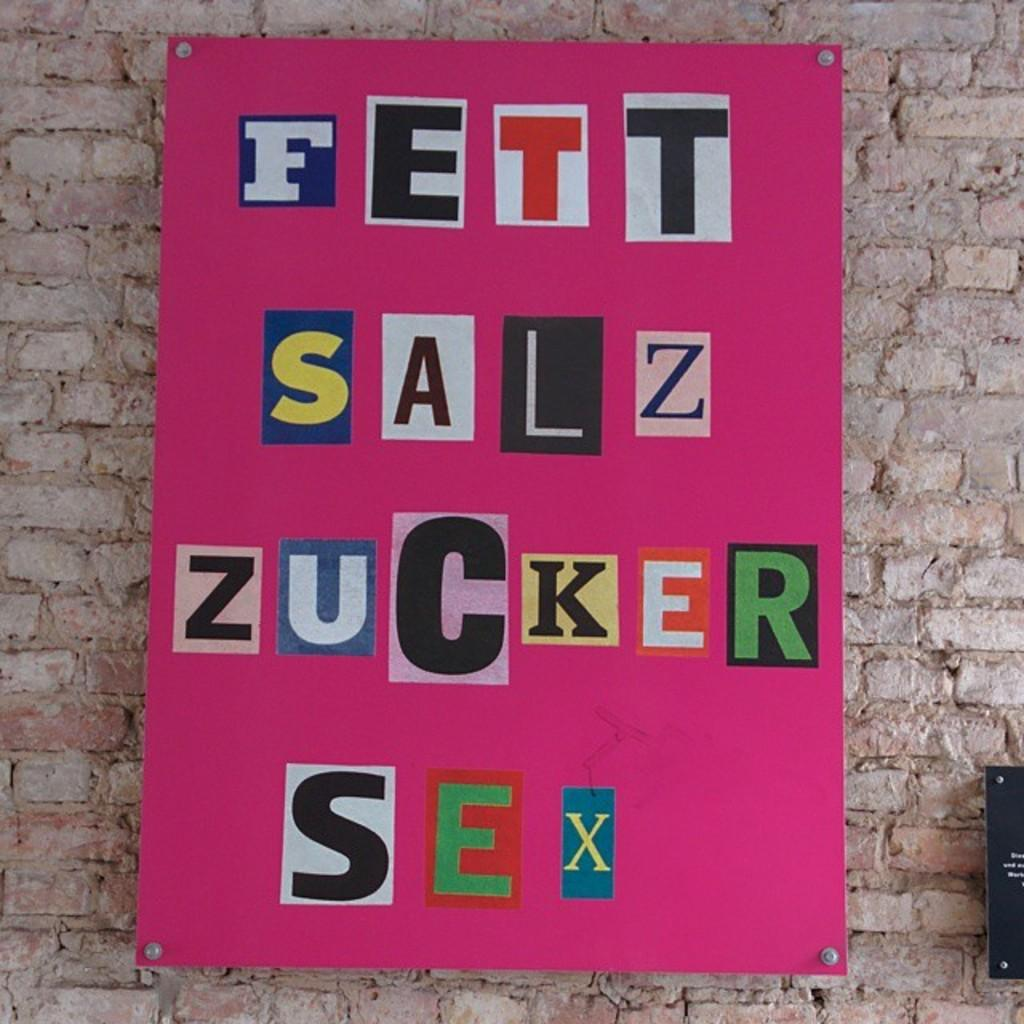<image>
Give a short and clear explanation of the subsequent image. On the brick wall hanging a pink board with german words " Fett Salz Zucker Sex" 